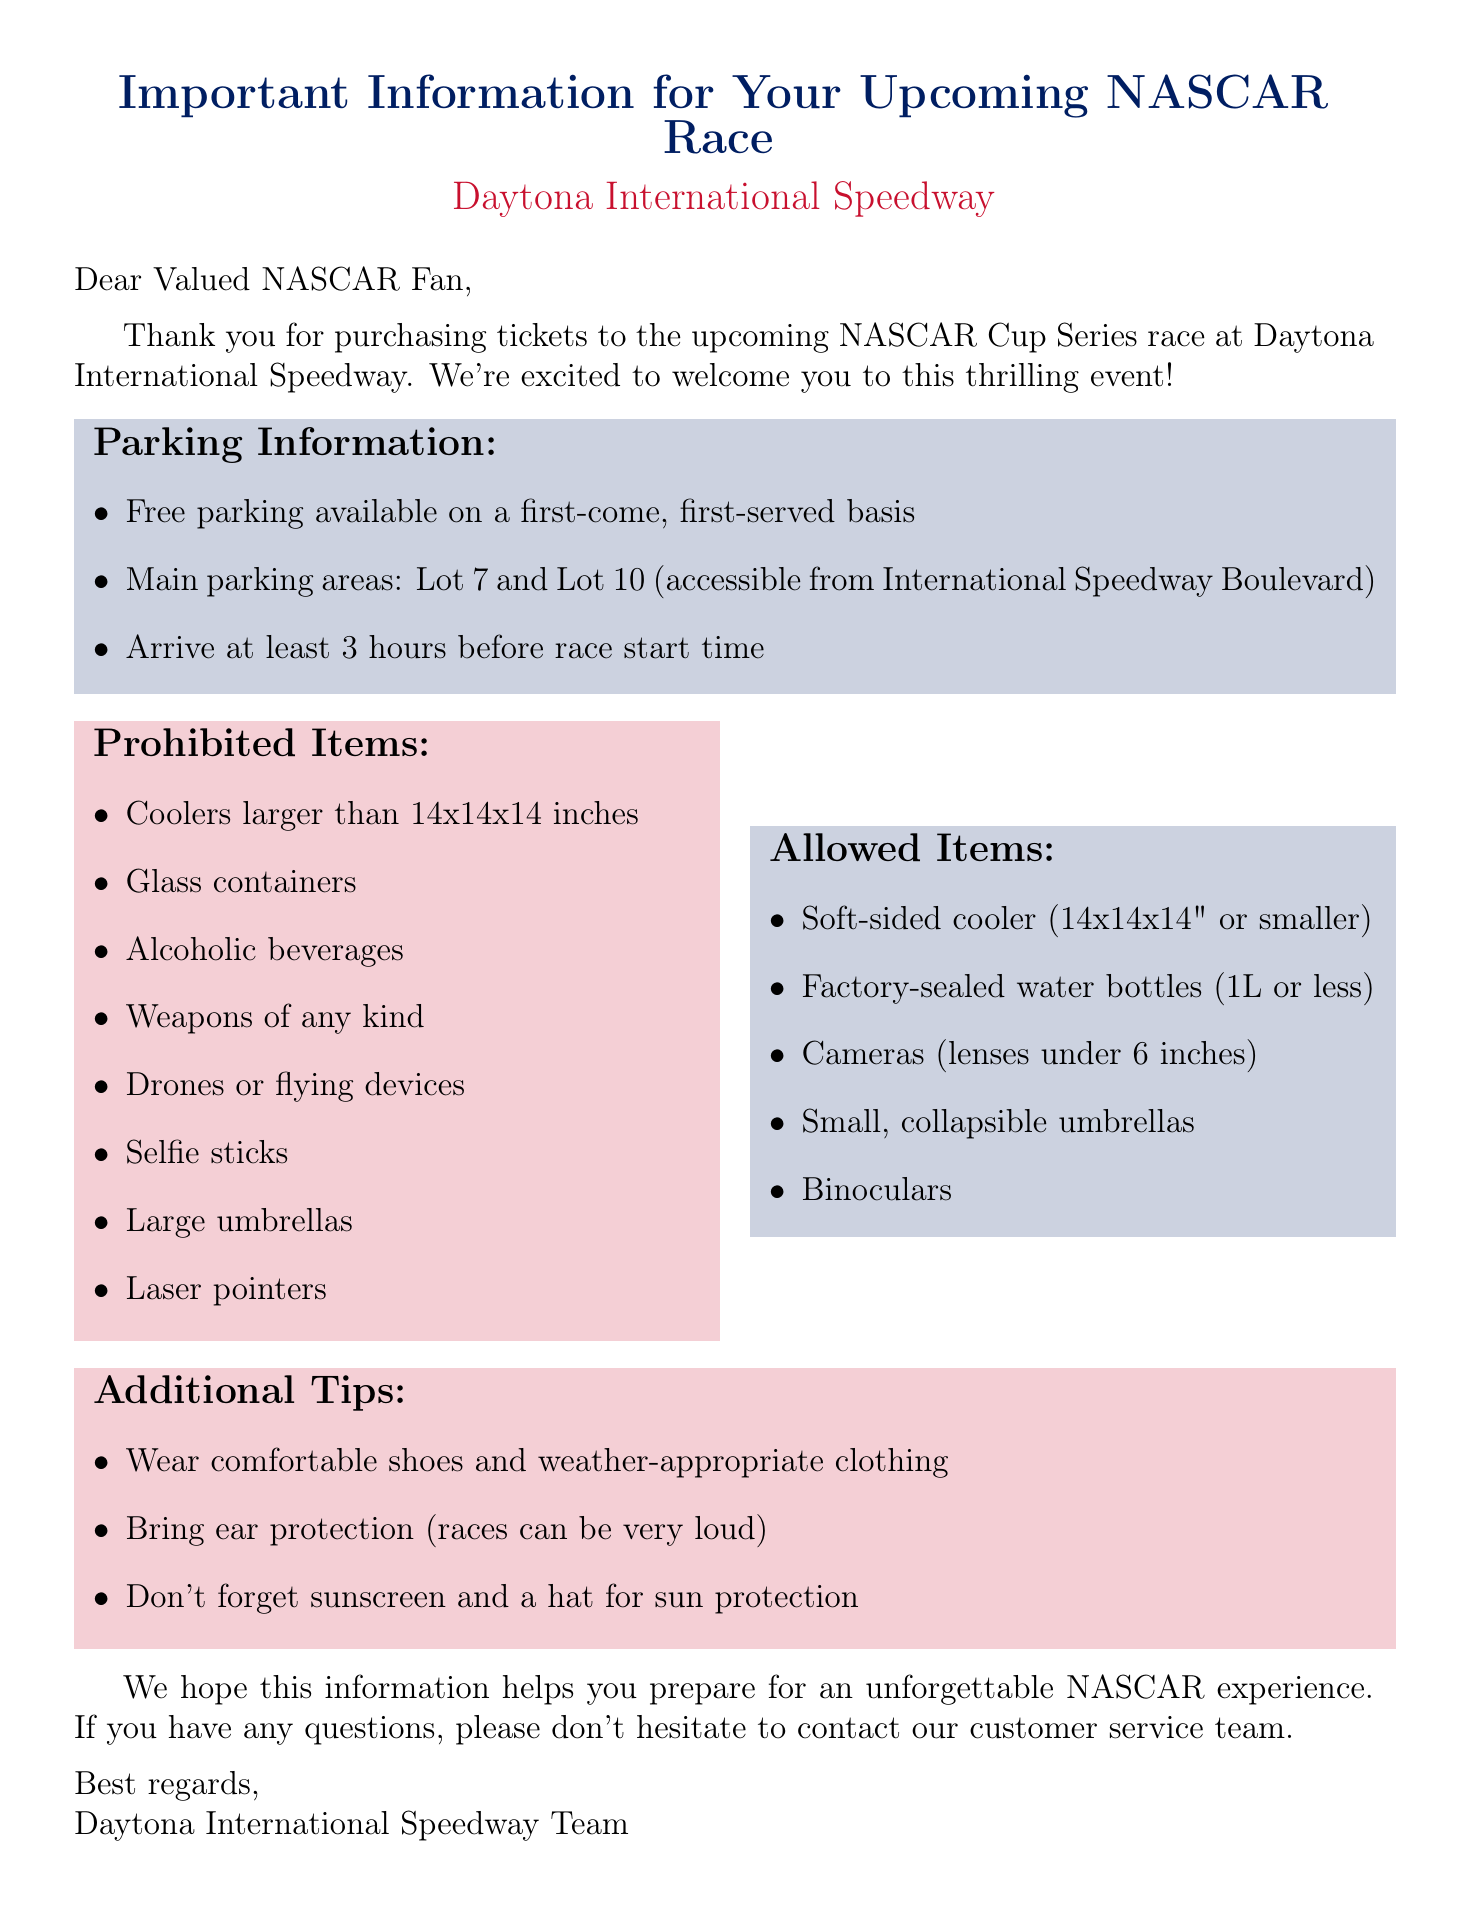What is the parking fee at Daytona International Speedway? The parking is free and available on a first-come, first-served basis.
Answer: Free What time should I arrive for parking? It is recommended to arrive at least 3 hours before the race start time.
Answer: 3 hours Which lots are the main parking areas? The main parking areas are Lot 7 and Lot 10, accessible from International Speedway Boulevard.
Answer: Lot 7 and Lot 10 What size coolers are prohibited? Coolers larger than 14x14x14 inches are not allowed.
Answer: Larger than 14x14x14 inches What should I wear to the race? Wearing comfortable shoes and dressing for the weather is recommended.
Answer: Comfortable shoes and weather-appropriate clothing What items are allowed? One soft-sided cooler (14x14x14 inches or smaller) is allowed.
Answer: One soft-sided cooler (14x14x14 inches or smaller) Which devices are prohibited at the event? Drones or other remote-controlled flying devices are not permitted.
Answer: Drones or other remote-controlled flying devices Who can I contact for questions? The customer service team can be contacted for any questions.
Answer: Customer service team 